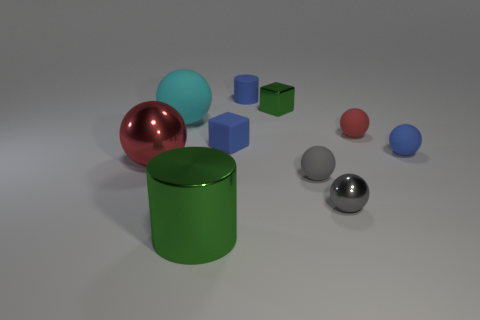What size is the red matte thing that is the same shape as the gray shiny thing?
Provide a short and direct response. Small. There is a thing that is in front of the small gray rubber ball and on the right side of the tiny blue rubber block; what is its material?
Your response must be concise. Metal. There is a green thing that is behind the blue rubber sphere; what size is it?
Offer a very short reply. Small. The other shiny object that is the same shape as the red metallic thing is what color?
Your answer should be very brief. Gray. Do the cylinder that is in front of the blue cylinder and the tiny green cube have the same size?
Make the answer very short. No. What shape is the tiny thing that is the same color as the metal cylinder?
Offer a very short reply. Cube. How many green objects have the same material as the green block?
Make the answer very short. 1. There is a block right of the cube that is in front of the big thing that is behind the red rubber object; what is it made of?
Provide a succinct answer. Metal. What is the color of the ball to the left of the large ball that is behind the small blue sphere?
Your answer should be compact. Red. There is a matte cube that is the same size as the gray matte thing; what is its color?
Give a very brief answer. Blue. 